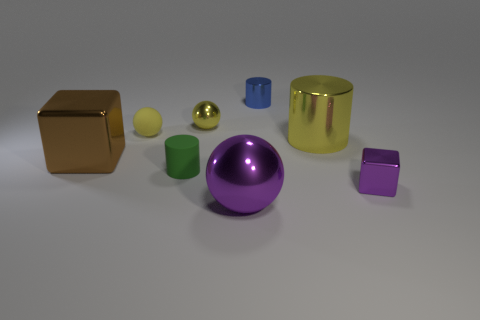Add 1 blue shiny cylinders. How many objects exist? 9 Subtract all large metallic spheres. How many spheres are left? 2 Subtract all yellow balls. How many balls are left? 1 Subtract all gray balls. How many blue cylinders are left? 1 Add 8 purple matte blocks. How many purple matte blocks exist? 8 Subtract 0 red cubes. How many objects are left? 8 Subtract all cubes. How many objects are left? 6 Subtract 3 cylinders. How many cylinders are left? 0 Subtract all purple blocks. Subtract all brown cylinders. How many blocks are left? 1 Subtract all large metal cylinders. Subtract all small purple metallic cubes. How many objects are left? 6 